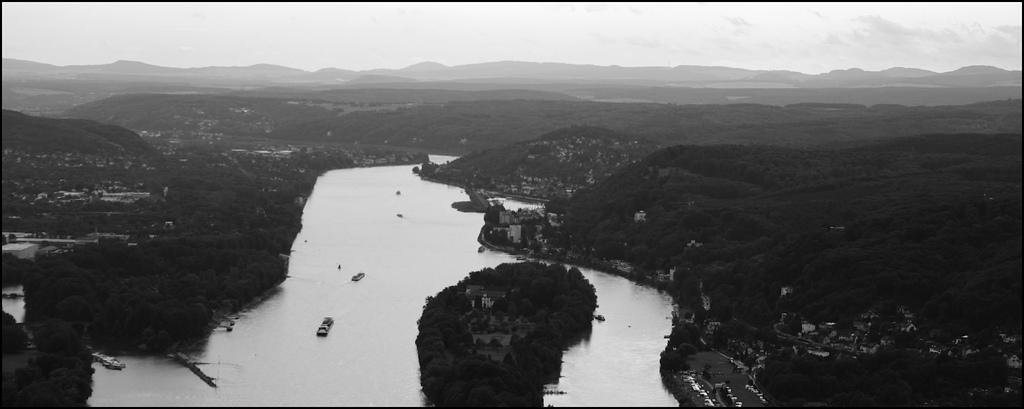What type of vehicles can be seen in the image? There are boats in the image. What type of natural features are present in the image? There are trees and mountains in the image. What type of environment is depicted in the image? There is water visible in the image, suggesting a waterfront or lake setting. What type of man-made structures are present in the image? There are buildings in the image. What is the color scheme of the image? The image is in black and white. How does the string help the boats in the image? There is no string present in the image, so it cannot help the boats. What type of attack is being carried out in the image? There is no attack present in the image; it depicts boats, trees, water, mountains, buildings, and is in black and white. 